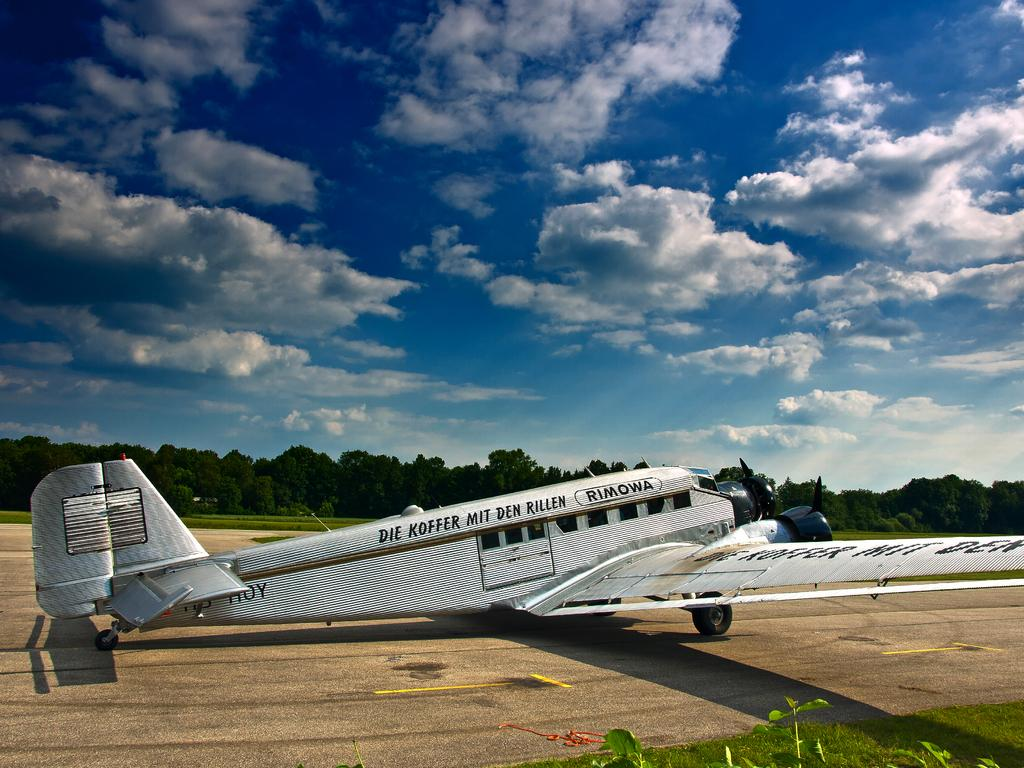<image>
Give a short and clear explanation of the subsequent image. An airplane has writing on the side which says, "Rimowa." 